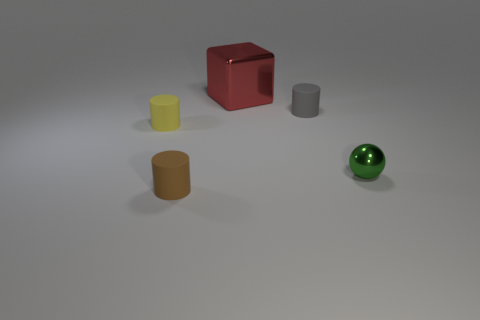Is there any other thing that has the same size as the metallic block?
Keep it short and to the point. No. How many other objects are the same material as the yellow object?
Offer a terse response. 2. There is a green object that is the same size as the brown rubber cylinder; what is it made of?
Your answer should be compact. Metal. Is the number of objects in front of the small yellow thing greater than the number of large red things to the left of the large red object?
Your answer should be compact. Yes. Is there another tiny object that has the same shape as the yellow rubber object?
Make the answer very short. Yes. What is the shape of the brown thing that is the same size as the green metallic object?
Ensure brevity in your answer.  Cylinder. There is a tiny rubber thing that is in front of the tiny shiny sphere; what is its shape?
Offer a very short reply. Cylinder. Are there fewer tiny green shiny things left of the gray rubber cylinder than small gray cylinders in front of the tiny yellow cylinder?
Offer a terse response. No. There is a gray object; is it the same size as the metallic object that is behind the yellow object?
Offer a terse response. No. What number of cyan metallic balls have the same size as the gray thing?
Offer a terse response. 0. 